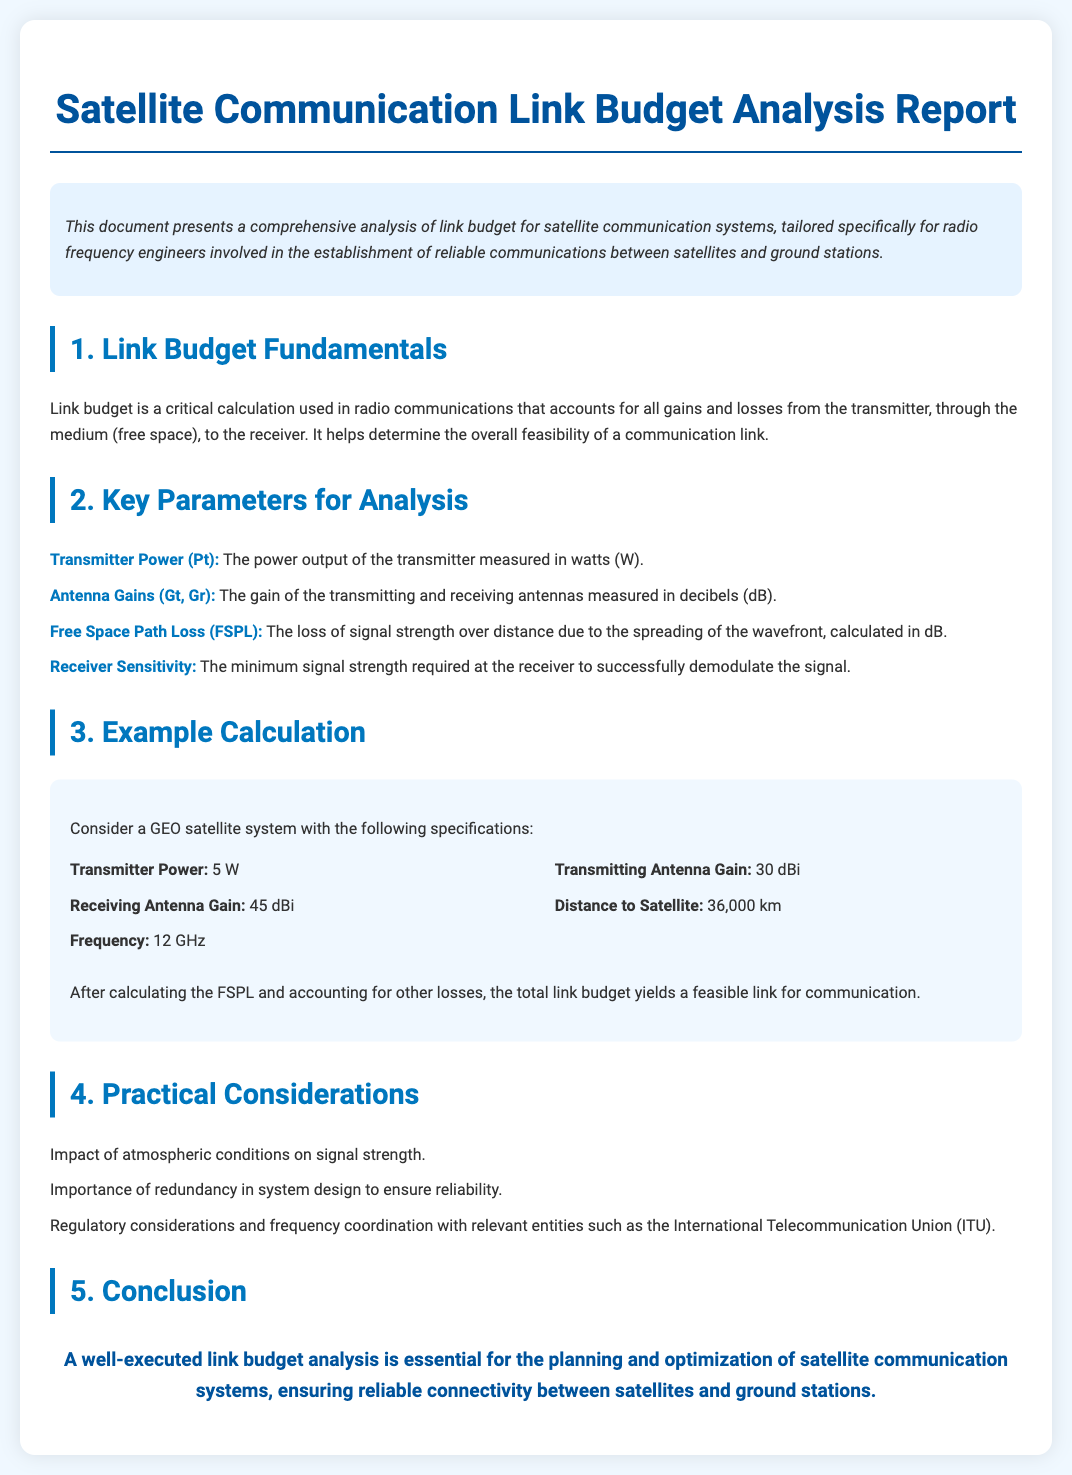what is the power output of the transmitter? The document specifies the transmitter power as 5 W.
Answer: 5 W what is the distance to the satellite? The report states that the distance to the satellite is 36,000 km.
Answer: 36,000 km what frequency is used in the example calculation? The document mentions that the frequency used is 12 GHz.
Answer: 12 GHz what is the receiving antenna gain? According to the specifications, the receiving antenna gain is 45 dBi.
Answer: 45 dBi what is the role of link budget in satellite communication? Link budget is crucial as it determines the overall feasibility of a communication link.
Answer: feasibility of a communication link what type of satellite system is discussed in the example? The example calculation discusses a GEO satellite system.
Answer: GEO satellite system what are two practical considerations mentioned in the report? The report highlights the impact of atmospheric conditions and redundancy in system design.
Answer: atmospheric conditions, redundancy what is the minimum signal strength required at the receiver known as? This is referred to as the receiver sensitivity in the document.
Answer: receiver sensitivity what is the main conclusion of the document? The conclusion emphasizes that link budget analysis is essential for reliable connectivity.
Answer: reliable connectivity 